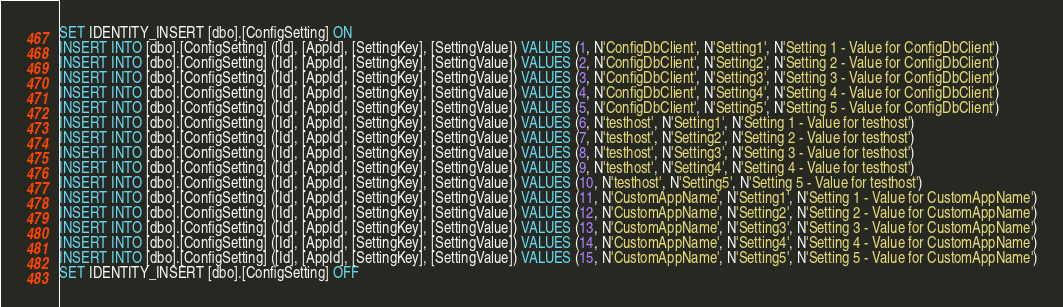Convert code to text. <code><loc_0><loc_0><loc_500><loc_500><_SQL_>SET IDENTITY_INSERT [dbo].[ConfigSetting] ON
INSERT INTO [dbo].[ConfigSetting] ([Id], [AppId], [SettingKey], [SettingValue]) VALUES (1, N'ConfigDbClient', N'Setting1', N'Setting 1 - Value for ConfigDbClient')
INSERT INTO [dbo].[ConfigSetting] ([Id], [AppId], [SettingKey], [SettingValue]) VALUES (2, N'ConfigDbClient', N'Setting2', N'Setting 2 - Value for ConfigDbClient')
INSERT INTO [dbo].[ConfigSetting] ([Id], [AppId], [SettingKey], [SettingValue]) VALUES (3, N'ConfigDbClient', N'Setting3', N'Setting 3 - Value for ConfigDbClient')
INSERT INTO [dbo].[ConfigSetting] ([Id], [AppId], [SettingKey], [SettingValue]) VALUES (4, N'ConfigDbClient', N'Setting4', N'Setting 4 - Value for ConfigDbClient')
INSERT INTO [dbo].[ConfigSetting] ([Id], [AppId], [SettingKey], [SettingValue]) VALUES (5, N'ConfigDbClient', N'Setting5', N'Setting 5 - Value for ConfigDbClient')
INSERT INTO [dbo].[ConfigSetting] ([Id], [AppId], [SettingKey], [SettingValue]) VALUES (6, N'testhost', N'Setting1', N'Setting 1 - Value for testhost')
INSERT INTO [dbo].[ConfigSetting] ([Id], [AppId], [SettingKey], [SettingValue]) VALUES (7, N'testhost', N'Setting2', N'Setting 2 - Value for testhost')
INSERT INTO [dbo].[ConfigSetting] ([Id], [AppId], [SettingKey], [SettingValue]) VALUES (8, N'testhost', N'Setting3', N'Setting 3 - Value for testhost')
INSERT INTO [dbo].[ConfigSetting] ([Id], [AppId], [SettingKey], [SettingValue]) VALUES (9, N'testhost', N'Setting4', N'Setting 4 - Value for testhost')
INSERT INTO [dbo].[ConfigSetting] ([Id], [AppId], [SettingKey], [SettingValue]) VALUES (10, N'testhost', N'Setting5', N'Setting 5 - Value for testhost')
INSERT INTO [dbo].[ConfigSetting] ([Id], [AppId], [SettingKey], [SettingValue]) VALUES (11, N'CustomAppName', N'Setting1', N'Setting 1 - Value for CustomAppName')
INSERT INTO [dbo].[ConfigSetting] ([Id], [AppId], [SettingKey], [SettingValue]) VALUES (12, N'CustomAppName', N'Setting2', N'Setting 2 - Value for CustomAppName')
INSERT INTO [dbo].[ConfigSetting] ([Id], [AppId], [SettingKey], [SettingValue]) VALUES (13, N'CustomAppName', N'Setting3', N'Setting 3 - Value for CustomAppName')
INSERT INTO [dbo].[ConfigSetting] ([Id], [AppId], [SettingKey], [SettingValue]) VALUES (14, N'CustomAppName', N'Setting4', N'Setting 4 - Value for CustomAppName')
INSERT INTO [dbo].[ConfigSetting] ([Id], [AppId], [SettingKey], [SettingValue]) VALUES (15, N'CustomAppName', N'Setting5', N'Setting 5 - Value for CustomAppName')
SET IDENTITY_INSERT [dbo].[ConfigSetting] OFF
</code> 